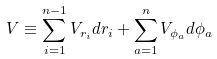<formula> <loc_0><loc_0><loc_500><loc_500>V & \equiv \sum _ { i = 1 } ^ { n - 1 } V _ { r _ { i } } d r _ { i } + \sum _ { a = 1 } ^ { n } V _ { \phi _ { a } } d \phi _ { a }</formula> 